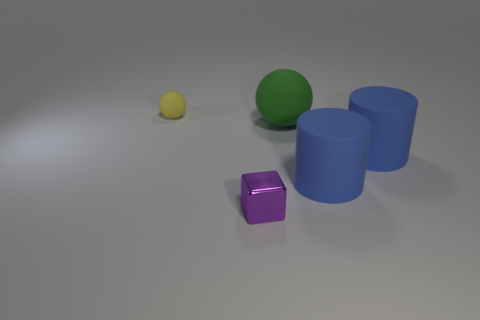Add 5 large blue rubber cylinders. How many objects exist? 10 Subtract all spheres. How many objects are left? 3 Subtract all purple metal objects. Subtract all purple metal cubes. How many objects are left? 3 Add 1 small yellow matte objects. How many small yellow matte objects are left? 2 Add 5 small cyan cubes. How many small cyan cubes exist? 5 Subtract 0 blue balls. How many objects are left? 5 